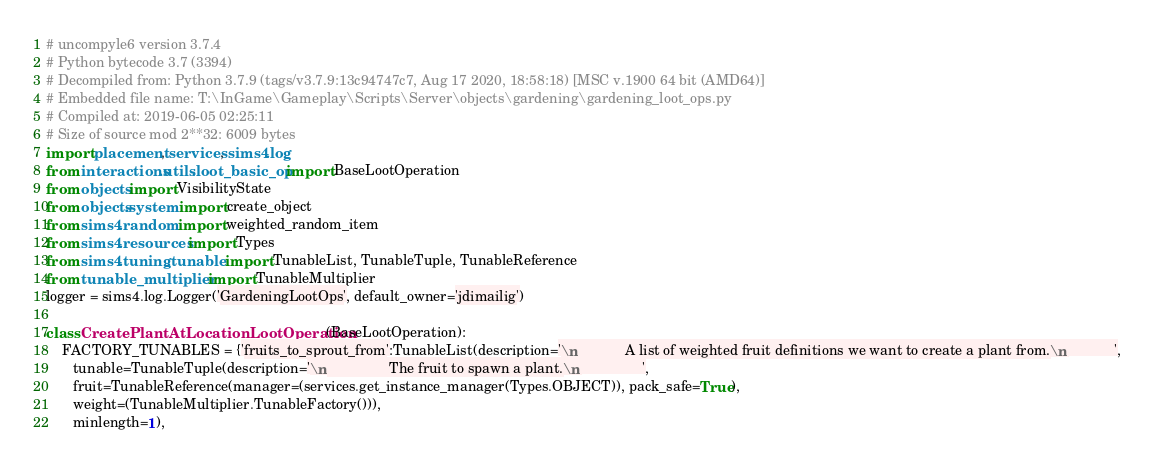Convert code to text. <code><loc_0><loc_0><loc_500><loc_500><_Python_># uncompyle6 version 3.7.4
# Python bytecode 3.7 (3394)
# Decompiled from: Python 3.7.9 (tags/v3.7.9:13c94747c7, Aug 17 2020, 18:58:18) [MSC v.1900 64 bit (AMD64)]
# Embedded file name: T:\InGame\Gameplay\Scripts\Server\objects\gardening\gardening_loot_ops.py
# Compiled at: 2019-06-05 02:25:11
# Size of source mod 2**32: 6009 bytes
import placement, services, sims4.log
from interactions.utils.loot_basic_op import BaseLootOperation
from objects import VisibilityState
from objects.system import create_object
from sims4.random import weighted_random_item
from sims4.resources import Types
from sims4.tuning.tunable import TunableList, TunableTuple, TunableReference
from tunable_multiplier import TunableMultiplier
logger = sims4.log.Logger('GardeningLootOps', default_owner='jdimailig')

class CreatePlantAtLocationLootOperation(BaseLootOperation):
    FACTORY_TUNABLES = {'fruits_to_sprout_from':TunableList(description='\n            A list of weighted fruit definitions we want to create a plant from.\n            ',
       tunable=TunableTuple(description='\n                The fruit to spawn a plant.\n                ',
       fruit=TunableReference(manager=(services.get_instance_manager(Types.OBJECT)), pack_safe=True),
       weight=(TunableMultiplier.TunableFactory())),
       minlength=1), </code> 